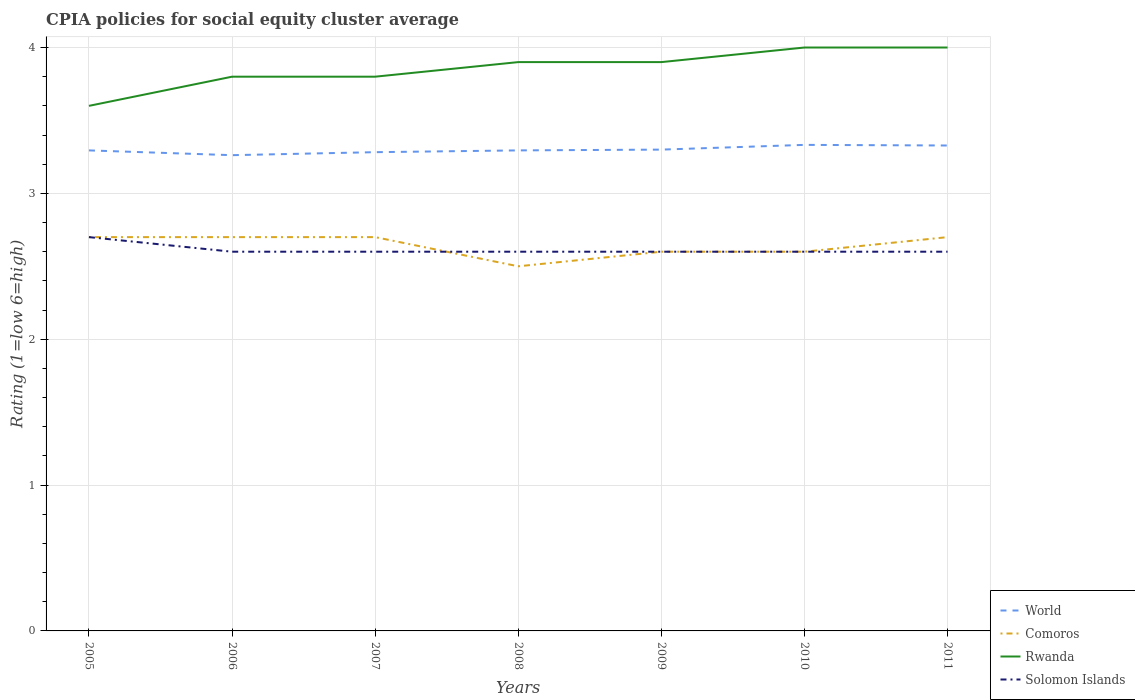How many different coloured lines are there?
Your answer should be very brief. 4. Does the line corresponding to World intersect with the line corresponding to Rwanda?
Your answer should be very brief. No. In which year was the CPIA rating in Rwanda maximum?
Provide a succinct answer. 2005. What is the total CPIA rating in Comoros in the graph?
Keep it short and to the point. 0. What is the difference between the highest and the second highest CPIA rating in Rwanda?
Provide a succinct answer. 0.4. What is the difference between the highest and the lowest CPIA rating in Solomon Islands?
Your response must be concise. 1. Is the CPIA rating in World strictly greater than the CPIA rating in Comoros over the years?
Your answer should be very brief. No. How many lines are there?
Your answer should be compact. 4. How many years are there in the graph?
Ensure brevity in your answer.  7. Does the graph contain any zero values?
Make the answer very short. No. Where does the legend appear in the graph?
Your answer should be very brief. Bottom right. How are the legend labels stacked?
Ensure brevity in your answer.  Vertical. What is the title of the graph?
Offer a terse response. CPIA policies for social equity cluster average. What is the label or title of the X-axis?
Provide a short and direct response. Years. What is the Rating (1=low 6=high) of World in 2005?
Provide a short and direct response. 3.29. What is the Rating (1=low 6=high) of World in 2006?
Offer a very short reply. 3.26. What is the Rating (1=low 6=high) of World in 2007?
Provide a short and direct response. 3.28. What is the Rating (1=low 6=high) of Rwanda in 2007?
Ensure brevity in your answer.  3.8. What is the Rating (1=low 6=high) in Solomon Islands in 2007?
Your response must be concise. 2.6. What is the Rating (1=low 6=high) in World in 2008?
Make the answer very short. 3.29. What is the Rating (1=low 6=high) of Rwanda in 2008?
Give a very brief answer. 3.9. What is the Rating (1=low 6=high) in Solomon Islands in 2008?
Offer a very short reply. 2.6. What is the Rating (1=low 6=high) of World in 2009?
Provide a succinct answer. 3.3. What is the Rating (1=low 6=high) of Comoros in 2009?
Keep it short and to the point. 2.6. What is the Rating (1=low 6=high) in World in 2010?
Your answer should be compact. 3.33. What is the Rating (1=low 6=high) in Solomon Islands in 2010?
Offer a very short reply. 2.6. What is the Rating (1=low 6=high) of World in 2011?
Make the answer very short. 3.33. What is the Rating (1=low 6=high) of Comoros in 2011?
Provide a succinct answer. 2.7. What is the Rating (1=low 6=high) in Rwanda in 2011?
Offer a terse response. 4. Across all years, what is the maximum Rating (1=low 6=high) in World?
Ensure brevity in your answer.  3.33. Across all years, what is the minimum Rating (1=low 6=high) in World?
Provide a succinct answer. 3.26. Across all years, what is the minimum Rating (1=low 6=high) in Comoros?
Give a very brief answer. 2.5. Across all years, what is the minimum Rating (1=low 6=high) in Rwanda?
Provide a succinct answer. 3.6. Across all years, what is the minimum Rating (1=low 6=high) of Solomon Islands?
Your answer should be compact. 2.6. What is the total Rating (1=low 6=high) in World in the graph?
Give a very brief answer. 23.09. What is the total Rating (1=low 6=high) in Comoros in the graph?
Your answer should be compact. 18.5. What is the total Rating (1=low 6=high) of Rwanda in the graph?
Offer a very short reply. 27. What is the difference between the Rating (1=low 6=high) in World in 2005 and that in 2006?
Offer a very short reply. 0.03. What is the difference between the Rating (1=low 6=high) of Rwanda in 2005 and that in 2006?
Provide a succinct answer. -0.2. What is the difference between the Rating (1=low 6=high) of Solomon Islands in 2005 and that in 2006?
Provide a short and direct response. 0.1. What is the difference between the Rating (1=low 6=high) of World in 2005 and that in 2007?
Your answer should be compact. 0.01. What is the difference between the Rating (1=low 6=high) in World in 2005 and that in 2008?
Keep it short and to the point. -0. What is the difference between the Rating (1=low 6=high) of Comoros in 2005 and that in 2008?
Your response must be concise. 0.2. What is the difference between the Rating (1=low 6=high) of Rwanda in 2005 and that in 2008?
Keep it short and to the point. -0.3. What is the difference between the Rating (1=low 6=high) of World in 2005 and that in 2009?
Keep it short and to the point. -0.01. What is the difference between the Rating (1=low 6=high) in Comoros in 2005 and that in 2009?
Your answer should be very brief. 0.1. What is the difference between the Rating (1=low 6=high) of Rwanda in 2005 and that in 2009?
Your answer should be very brief. -0.3. What is the difference between the Rating (1=low 6=high) in World in 2005 and that in 2010?
Your response must be concise. -0.04. What is the difference between the Rating (1=low 6=high) in Comoros in 2005 and that in 2010?
Provide a succinct answer. 0.1. What is the difference between the Rating (1=low 6=high) in Rwanda in 2005 and that in 2010?
Your response must be concise. -0.4. What is the difference between the Rating (1=low 6=high) of World in 2005 and that in 2011?
Provide a short and direct response. -0.03. What is the difference between the Rating (1=low 6=high) of Rwanda in 2005 and that in 2011?
Give a very brief answer. -0.4. What is the difference between the Rating (1=low 6=high) in World in 2006 and that in 2007?
Ensure brevity in your answer.  -0.02. What is the difference between the Rating (1=low 6=high) in Comoros in 2006 and that in 2007?
Keep it short and to the point. 0. What is the difference between the Rating (1=low 6=high) of Rwanda in 2006 and that in 2007?
Give a very brief answer. 0. What is the difference between the Rating (1=low 6=high) of World in 2006 and that in 2008?
Your answer should be very brief. -0.03. What is the difference between the Rating (1=low 6=high) of Comoros in 2006 and that in 2008?
Keep it short and to the point. 0.2. What is the difference between the Rating (1=low 6=high) in Rwanda in 2006 and that in 2008?
Ensure brevity in your answer.  -0.1. What is the difference between the Rating (1=low 6=high) in Solomon Islands in 2006 and that in 2008?
Your answer should be very brief. 0. What is the difference between the Rating (1=low 6=high) in World in 2006 and that in 2009?
Keep it short and to the point. -0.04. What is the difference between the Rating (1=low 6=high) of World in 2006 and that in 2010?
Your answer should be compact. -0.07. What is the difference between the Rating (1=low 6=high) in Solomon Islands in 2006 and that in 2010?
Make the answer very short. 0. What is the difference between the Rating (1=low 6=high) of World in 2006 and that in 2011?
Offer a very short reply. -0.07. What is the difference between the Rating (1=low 6=high) in Comoros in 2006 and that in 2011?
Your answer should be compact. 0. What is the difference between the Rating (1=low 6=high) of Solomon Islands in 2006 and that in 2011?
Make the answer very short. 0. What is the difference between the Rating (1=low 6=high) of World in 2007 and that in 2008?
Provide a succinct answer. -0.01. What is the difference between the Rating (1=low 6=high) in Comoros in 2007 and that in 2008?
Ensure brevity in your answer.  0.2. What is the difference between the Rating (1=low 6=high) in Rwanda in 2007 and that in 2008?
Give a very brief answer. -0.1. What is the difference between the Rating (1=low 6=high) in Solomon Islands in 2007 and that in 2008?
Keep it short and to the point. 0. What is the difference between the Rating (1=low 6=high) in World in 2007 and that in 2009?
Your answer should be compact. -0.02. What is the difference between the Rating (1=low 6=high) in Comoros in 2007 and that in 2009?
Your answer should be compact. 0.1. What is the difference between the Rating (1=low 6=high) in Rwanda in 2007 and that in 2009?
Keep it short and to the point. -0.1. What is the difference between the Rating (1=low 6=high) in Solomon Islands in 2007 and that in 2009?
Make the answer very short. 0. What is the difference between the Rating (1=low 6=high) in Rwanda in 2007 and that in 2010?
Your response must be concise. -0.2. What is the difference between the Rating (1=low 6=high) in Solomon Islands in 2007 and that in 2010?
Provide a short and direct response. 0. What is the difference between the Rating (1=low 6=high) of World in 2007 and that in 2011?
Keep it short and to the point. -0.05. What is the difference between the Rating (1=low 6=high) of Rwanda in 2007 and that in 2011?
Provide a succinct answer. -0.2. What is the difference between the Rating (1=low 6=high) of Solomon Islands in 2007 and that in 2011?
Give a very brief answer. 0. What is the difference between the Rating (1=low 6=high) of World in 2008 and that in 2009?
Ensure brevity in your answer.  -0.01. What is the difference between the Rating (1=low 6=high) of Comoros in 2008 and that in 2009?
Provide a short and direct response. -0.1. What is the difference between the Rating (1=low 6=high) in World in 2008 and that in 2010?
Provide a succinct answer. -0.04. What is the difference between the Rating (1=low 6=high) in Comoros in 2008 and that in 2010?
Provide a short and direct response. -0.1. What is the difference between the Rating (1=low 6=high) of Rwanda in 2008 and that in 2010?
Provide a short and direct response. -0.1. What is the difference between the Rating (1=low 6=high) in World in 2008 and that in 2011?
Offer a terse response. -0.03. What is the difference between the Rating (1=low 6=high) of Rwanda in 2008 and that in 2011?
Offer a very short reply. -0.1. What is the difference between the Rating (1=low 6=high) in World in 2009 and that in 2010?
Offer a very short reply. -0.03. What is the difference between the Rating (1=low 6=high) in Solomon Islands in 2009 and that in 2010?
Offer a terse response. 0. What is the difference between the Rating (1=low 6=high) in World in 2009 and that in 2011?
Your answer should be compact. -0.03. What is the difference between the Rating (1=low 6=high) of Solomon Islands in 2009 and that in 2011?
Offer a very short reply. 0. What is the difference between the Rating (1=low 6=high) in World in 2010 and that in 2011?
Your answer should be compact. 0. What is the difference between the Rating (1=low 6=high) in Comoros in 2010 and that in 2011?
Offer a very short reply. -0.1. What is the difference between the Rating (1=low 6=high) of World in 2005 and the Rating (1=low 6=high) of Comoros in 2006?
Offer a very short reply. 0.59. What is the difference between the Rating (1=low 6=high) in World in 2005 and the Rating (1=low 6=high) in Rwanda in 2006?
Give a very brief answer. -0.51. What is the difference between the Rating (1=low 6=high) in World in 2005 and the Rating (1=low 6=high) in Solomon Islands in 2006?
Your answer should be compact. 0.69. What is the difference between the Rating (1=low 6=high) in World in 2005 and the Rating (1=low 6=high) in Comoros in 2007?
Make the answer very short. 0.59. What is the difference between the Rating (1=low 6=high) in World in 2005 and the Rating (1=low 6=high) in Rwanda in 2007?
Your response must be concise. -0.51. What is the difference between the Rating (1=low 6=high) in World in 2005 and the Rating (1=low 6=high) in Solomon Islands in 2007?
Ensure brevity in your answer.  0.69. What is the difference between the Rating (1=low 6=high) in World in 2005 and the Rating (1=low 6=high) in Comoros in 2008?
Ensure brevity in your answer.  0.79. What is the difference between the Rating (1=low 6=high) in World in 2005 and the Rating (1=low 6=high) in Rwanda in 2008?
Offer a very short reply. -0.61. What is the difference between the Rating (1=low 6=high) of World in 2005 and the Rating (1=low 6=high) of Solomon Islands in 2008?
Your response must be concise. 0.69. What is the difference between the Rating (1=low 6=high) of Comoros in 2005 and the Rating (1=low 6=high) of Rwanda in 2008?
Keep it short and to the point. -1.2. What is the difference between the Rating (1=low 6=high) in Rwanda in 2005 and the Rating (1=low 6=high) in Solomon Islands in 2008?
Your answer should be compact. 1. What is the difference between the Rating (1=low 6=high) of World in 2005 and the Rating (1=low 6=high) of Comoros in 2009?
Provide a short and direct response. 0.69. What is the difference between the Rating (1=low 6=high) in World in 2005 and the Rating (1=low 6=high) in Rwanda in 2009?
Offer a terse response. -0.61. What is the difference between the Rating (1=low 6=high) of World in 2005 and the Rating (1=low 6=high) of Solomon Islands in 2009?
Offer a very short reply. 0.69. What is the difference between the Rating (1=low 6=high) in Comoros in 2005 and the Rating (1=low 6=high) in Rwanda in 2009?
Offer a very short reply. -1.2. What is the difference between the Rating (1=low 6=high) of Rwanda in 2005 and the Rating (1=low 6=high) of Solomon Islands in 2009?
Offer a very short reply. 1. What is the difference between the Rating (1=low 6=high) in World in 2005 and the Rating (1=low 6=high) in Comoros in 2010?
Offer a terse response. 0.69. What is the difference between the Rating (1=low 6=high) in World in 2005 and the Rating (1=low 6=high) in Rwanda in 2010?
Your response must be concise. -0.71. What is the difference between the Rating (1=low 6=high) of World in 2005 and the Rating (1=low 6=high) of Solomon Islands in 2010?
Make the answer very short. 0.69. What is the difference between the Rating (1=low 6=high) in Rwanda in 2005 and the Rating (1=low 6=high) in Solomon Islands in 2010?
Make the answer very short. 1. What is the difference between the Rating (1=low 6=high) of World in 2005 and the Rating (1=low 6=high) of Comoros in 2011?
Ensure brevity in your answer.  0.59. What is the difference between the Rating (1=low 6=high) in World in 2005 and the Rating (1=low 6=high) in Rwanda in 2011?
Keep it short and to the point. -0.71. What is the difference between the Rating (1=low 6=high) of World in 2005 and the Rating (1=low 6=high) of Solomon Islands in 2011?
Your response must be concise. 0.69. What is the difference between the Rating (1=low 6=high) of Rwanda in 2005 and the Rating (1=low 6=high) of Solomon Islands in 2011?
Make the answer very short. 1. What is the difference between the Rating (1=low 6=high) of World in 2006 and the Rating (1=low 6=high) of Comoros in 2007?
Give a very brief answer. 0.56. What is the difference between the Rating (1=low 6=high) of World in 2006 and the Rating (1=low 6=high) of Rwanda in 2007?
Offer a very short reply. -0.54. What is the difference between the Rating (1=low 6=high) in World in 2006 and the Rating (1=low 6=high) in Solomon Islands in 2007?
Offer a terse response. 0.66. What is the difference between the Rating (1=low 6=high) in Comoros in 2006 and the Rating (1=low 6=high) in Rwanda in 2007?
Your answer should be compact. -1.1. What is the difference between the Rating (1=low 6=high) in Comoros in 2006 and the Rating (1=low 6=high) in Solomon Islands in 2007?
Provide a short and direct response. 0.1. What is the difference between the Rating (1=low 6=high) of World in 2006 and the Rating (1=low 6=high) of Comoros in 2008?
Your answer should be compact. 0.76. What is the difference between the Rating (1=low 6=high) in World in 2006 and the Rating (1=low 6=high) in Rwanda in 2008?
Provide a short and direct response. -0.64. What is the difference between the Rating (1=low 6=high) in World in 2006 and the Rating (1=low 6=high) in Solomon Islands in 2008?
Provide a short and direct response. 0.66. What is the difference between the Rating (1=low 6=high) in World in 2006 and the Rating (1=low 6=high) in Comoros in 2009?
Offer a very short reply. 0.66. What is the difference between the Rating (1=low 6=high) of World in 2006 and the Rating (1=low 6=high) of Rwanda in 2009?
Offer a very short reply. -0.64. What is the difference between the Rating (1=low 6=high) of World in 2006 and the Rating (1=low 6=high) of Solomon Islands in 2009?
Provide a succinct answer. 0.66. What is the difference between the Rating (1=low 6=high) in World in 2006 and the Rating (1=low 6=high) in Comoros in 2010?
Ensure brevity in your answer.  0.66. What is the difference between the Rating (1=low 6=high) of World in 2006 and the Rating (1=low 6=high) of Rwanda in 2010?
Your answer should be very brief. -0.74. What is the difference between the Rating (1=low 6=high) of World in 2006 and the Rating (1=low 6=high) of Solomon Islands in 2010?
Provide a short and direct response. 0.66. What is the difference between the Rating (1=low 6=high) of World in 2006 and the Rating (1=low 6=high) of Comoros in 2011?
Keep it short and to the point. 0.56. What is the difference between the Rating (1=low 6=high) in World in 2006 and the Rating (1=low 6=high) in Rwanda in 2011?
Provide a short and direct response. -0.74. What is the difference between the Rating (1=low 6=high) in World in 2006 and the Rating (1=low 6=high) in Solomon Islands in 2011?
Offer a very short reply. 0.66. What is the difference between the Rating (1=low 6=high) of Comoros in 2006 and the Rating (1=low 6=high) of Rwanda in 2011?
Your answer should be compact. -1.3. What is the difference between the Rating (1=low 6=high) in Comoros in 2006 and the Rating (1=low 6=high) in Solomon Islands in 2011?
Make the answer very short. 0.1. What is the difference between the Rating (1=low 6=high) in World in 2007 and the Rating (1=low 6=high) in Comoros in 2008?
Your response must be concise. 0.78. What is the difference between the Rating (1=low 6=high) of World in 2007 and the Rating (1=low 6=high) of Rwanda in 2008?
Ensure brevity in your answer.  -0.62. What is the difference between the Rating (1=low 6=high) of World in 2007 and the Rating (1=low 6=high) of Solomon Islands in 2008?
Keep it short and to the point. 0.68. What is the difference between the Rating (1=low 6=high) of Comoros in 2007 and the Rating (1=low 6=high) of Solomon Islands in 2008?
Your answer should be compact. 0.1. What is the difference between the Rating (1=low 6=high) in Rwanda in 2007 and the Rating (1=low 6=high) in Solomon Islands in 2008?
Give a very brief answer. 1.2. What is the difference between the Rating (1=low 6=high) in World in 2007 and the Rating (1=low 6=high) in Comoros in 2009?
Offer a terse response. 0.68. What is the difference between the Rating (1=low 6=high) in World in 2007 and the Rating (1=low 6=high) in Rwanda in 2009?
Offer a very short reply. -0.62. What is the difference between the Rating (1=low 6=high) in World in 2007 and the Rating (1=low 6=high) in Solomon Islands in 2009?
Your answer should be very brief. 0.68. What is the difference between the Rating (1=low 6=high) of Comoros in 2007 and the Rating (1=low 6=high) of Solomon Islands in 2009?
Keep it short and to the point. 0.1. What is the difference between the Rating (1=low 6=high) of Rwanda in 2007 and the Rating (1=low 6=high) of Solomon Islands in 2009?
Ensure brevity in your answer.  1.2. What is the difference between the Rating (1=low 6=high) in World in 2007 and the Rating (1=low 6=high) in Comoros in 2010?
Your response must be concise. 0.68. What is the difference between the Rating (1=low 6=high) of World in 2007 and the Rating (1=low 6=high) of Rwanda in 2010?
Offer a very short reply. -0.72. What is the difference between the Rating (1=low 6=high) of World in 2007 and the Rating (1=low 6=high) of Solomon Islands in 2010?
Keep it short and to the point. 0.68. What is the difference between the Rating (1=low 6=high) in Comoros in 2007 and the Rating (1=low 6=high) in Rwanda in 2010?
Ensure brevity in your answer.  -1.3. What is the difference between the Rating (1=low 6=high) of Rwanda in 2007 and the Rating (1=low 6=high) of Solomon Islands in 2010?
Offer a terse response. 1.2. What is the difference between the Rating (1=low 6=high) of World in 2007 and the Rating (1=low 6=high) of Comoros in 2011?
Provide a short and direct response. 0.58. What is the difference between the Rating (1=low 6=high) of World in 2007 and the Rating (1=low 6=high) of Rwanda in 2011?
Make the answer very short. -0.72. What is the difference between the Rating (1=low 6=high) in World in 2007 and the Rating (1=low 6=high) in Solomon Islands in 2011?
Ensure brevity in your answer.  0.68. What is the difference between the Rating (1=low 6=high) in Comoros in 2007 and the Rating (1=low 6=high) in Rwanda in 2011?
Make the answer very short. -1.3. What is the difference between the Rating (1=low 6=high) in Comoros in 2007 and the Rating (1=low 6=high) in Solomon Islands in 2011?
Offer a very short reply. 0.1. What is the difference between the Rating (1=low 6=high) in Rwanda in 2007 and the Rating (1=low 6=high) in Solomon Islands in 2011?
Keep it short and to the point. 1.2. What is the difference between the Rating (1=low 6=high) of World in 2008 and the Rating (1=low 6=high) of Comoros in 2009?
Keep it short and to the point. 0.69. What is the difference between the Rating (1=low 6=high) of World in 2008 and the Rating (1=low 6=high) of Rwanda in 2009?
Offer a terse response. -0.61. What is the difference between the Rating (1=low 6=high) of World in 2008 and the Rating (1=low 6=high) of Solomon Islands in 2009?
Make the answer very short. 0.69. What is the difference between the Rating (1=low 6=high) of World in 2008 and the Rating (1=low 6=high) of Comoros in 2010?
Keep it short and to the point. 0.69. What is the difference between the Rating (1=low 6=high) of World in 2008 and the Rating (1=low 6=high) of Rwanda in 2010?
Provide a short and direct response. -0.71. What is the difference between the Rating (1=low 6=high) in World in 2008 and the Rating (1=low 6=high) in Solomon Islands in 2010?
Your response must be concise. 0.69. What is the difference between the Rating (1=low 6=high) of Comoros in 2008 and the Rating (1=low 6=high) of Rwanda in 2010?
Your answer should be very brief. -1.5. What is the difference between the Rating (1=low 6=high) of Comoros in 2008 and the Rating (1=low 6=high) of Solomon Islands in 2010?
Offer a very short reply. -0.1. What is the difference between the Rating (1=low 6=high) in Rwanda in 2008 and the Rating (1=low 6=high) in Solomon Islands in 2010?
Ensure brevity in your answer.  1.3. What is the difference between the Rating (1=low 6=high) in World in 2008 and the Rating (1=low 6=high) in Comoros in 2011?
Your answer should be very brief. 0.59. What is the difference between the Rating (1=low 6=high) in World in 2008 and the Rating (1=low 6=high) in Rwanda in 2011?
Offer a very short reply. -0.71. What is the difference between the Rating (1=low 6=high) of World in 2008 and the Rating (1=low 6=high) of Solomon Islands in 2011?
Provide a succinct answer. 0.69. What is the difference between the Rating (1=low 6=high) of Comoros in 2008 and the Rating (1=low 6=high) of Rwanda in 2011?
Keep it short and to the point. -1.5. What is the difference between the Rating (1=low 6=high) in Rwanda in 2008 and the Rating (1=low 6=high) in Solomon Islands in 2011?
Your response must be concise. 1.3. What is the difference between the Rating (1=low 6=high) of World in 2009 and the Rating (1=low 6=high) of Rwanda in 2010?
Make the answer very short. -0.7. What is the difference between the Rating (1=low 6=high) of Comoros in 2009 and the Rating (1=low 6=high) of Rwanda in 2010?
Offer a very short reply. -1.4. What is the difference between the Rating (1=low 6=high) in Rwanda in 2009 and the Rating (1=low 6=high) in Solomon Islands in 2010?
Offer a terse response. 1.3. What is the difference between the Rating (1=low 6=high) of World in 2009 and the Rating (1=low 6=high) of Rwanda in 2011?
Your answer should be very brief. -0.7. What is the difference between the Rating (1=low 6=high) in Comoros in 2009 and the Rating (1=low 6=high) in Rwanda in 2011?
Offer a terse response. -1.4. What is the difference between the Rating (1=low 6=high) in World in 2010 and the Rating (1=low 6=high) in Comoros in 2011?
Your answer should be compact. 0.63. What is the difference between the Rating (1=low 6=high) of World in 2010 and the Rating (1=low 6=high) of Rwanda in 2011?
Provide a short and direct response. -0.67. What is the difference between the Rating (1=low 6=high) in World in 2010 and the Rating (1=low 6=high) in Solomon Islands in 2011?
Give a very brief answer. 0.73. What is the difference between the Rating (1=low 6=high) of Comoros in 2010 and the Rating (1=low 6=high) of Solomon Islands in 2011?
Provide a succinct answer. 0. What is the difference between the Rating (1=low 6=high) of Rwanda in 2010 and the Rating (1=low 6=high) of Solomon Islands in 2011?
Give a very brief answer. 1.4. What is the average Rating (1=low 6=high) in World per year?
Provide a short and direct response. 3.3. What is the average Rating (1=low 6=high) of Comoros per year?
Provide a short and direct response. 2.64. What is the average Rating (1=low 6=high) of Rwanda per year?
Provide a short and direct response. 3.86. What is the average Rating (1=low 6=high) in Solomon Islands per year?
Your answer should be very brief. 2.61. In the year 2005, what is the difference between the Rating (1=low 6=high) of World and Rating (1=low 6=high) of Comoros?
Your answer should be very brief. 0.59. In the year 2005, what is the difference between the Rating (1=low 6=high) in World and Rating (1=low 6=high) in Rwanda?
Your answer should be compact. -0.31. In the year 2005, what is the difference between the Rating (1=low 6=high) in World and Rating (1=low 6=high) in Solomon Islands?
Provide a short and direct response. 0.59. In the year 2005, what is the difference between the Rating (1=low 6=high) of Comoros and Rating (1=low 6=high) of Solomon Islands?
Make the answer very short. 0. In the year 2006, what is the difference between the Rating (1=low 6=high) of World and Rating (1=low 6=high) of Comoros?
Provide a succinct answer. 0.56. In the year 2006, what is the difference between the Rating (1=low 6=high) in World and Rating (1=low 6=high) in Rwanda?
Offer a terse response. -0.54. In the year 2006, what is the difference between the Rating (1=low 6=high) of World and Rating (1=low 6=high) of Solomon Islands?
Make the answer very short. 0.66. In the year 2006, what is the difference between the Rating (1=low 6=high) of Comoros and Rating (1=low 6=high) of Rwanda?
Offer a very short reply. -1.1. In the year 2006, what is the difference between the Rating (1=low 6=high) in Comoros and Rating (1=low 6=high) in Solomon Islands?
Make the answer very short. 0.1. In the year 2007, what is the difference between the Rating (1=low 6=high) of World and Rating (1=low 6=high) of Comoros?
Provide a succinct answer. 0.58. In the year 2007, what is the difference between the Rating (1=low 6=high) in World and Rating (1=low 6=high) in Rwanda?
Ensure brevity in your answer.  -0.52. In the year 2007, what is the difference between the Rating (1=low 6=high) of World and Rating (1=low 6=high) of Solomon Islands?
Your answer should be very brief. 0.68. In the year 2007, what is the difference between the Rating (1=low 6=high) in Comoros and Rating (1=low 6=high) in Rwanda?
Make the answer very short. -1.1. In the year 2007, what is the difference between the Rating (1=low 6=high) in Comoros and Rating (1=low 6=high) in Solomon Islands?
Keep it short and to the point. 0.1. In the year 2007, what is the difference between the Rating (1=low 6=high) in Rwanda and Rating (1=low 6=high) in Solomon Islands?
Your response must be concise. 1.2. In the year 2008, what is the difference between the Rating (1=low 6=high) of World and Rating (1=low 6=high) of Comoros?
Ensure brevity in your answer.  0.79. In the year 2008, what is the difference between the Rating (1=low 6=high) of World and Rating (1=low 6=high) of Rwanda?
Make the answer very short. -0.61. In the year 2008, what is the difference between the Rating (1=low 6=high) in World and Rating (1=low 6=high) in Solomon Islands?
Ensure brevity in your answer.  0.69. In the year 2008, what is the difference between the Rating (1=low 6=high) in Comoros and Rating (1=low 6=high) in Rwanda?
Offer a terse response. -1.4. In the year 2009, what is the difference between the Rating (1=low 6=high) in World and Rating (1=low 6=high) in Comoros?
Provide a succinct answer. 0.7. In the year 2009, what is the difference between the Rating (1=low 6=high) in World and Rating (1=low 6=high) in Rwanda?
Keep it short and to the point. -0.6. In the year 2010, what is the difference between the Rating (1=low 6=high) of World and Rating (1=low 6=high) of Comoros?
Offer a very short reply. 0.73. In the year 2010, what is the difference between the Rating (1=low 6=high) of World and Rating (1=low 6=high) of Rwanda?
Give a very brief answer. -0.67. In the year 2010, what is the difference between the Rating (1=low 6=high) in World and Rating (1=low 6=high) in Solomon Islands?
Your answer should be very brief. 0.73. In the year 2011, what is the difference between the Rating (1=low 6=high) of World and Rating (1=low 6=high) of Comoros?
Provide a short and direct response. 0.63. In the year 2011, what is the difference between the Rating (1=low 6=high) in World and Rating (1=low 6=high) in Rwanda?
Your response must be concise. -0.67. In the year 2011, what is the difference between the Rating (1=low 6=high) of World and Rating (1=low 6=high) of Solomon Islands?
Ensure brevity in your answer.  0.73. In the year 2011, what is the difference between the Rating (1=low 6=high) in Comoros and Rating (1=low 6=high) in Solomon Islands?
Make the answer very short. 0.1. In the year 2011, what is the difference between the Rating (1=low 6=high) of Rwanda and Rating (1=low 6=high) of Solomon Islands?
Keep it short and to the point. 1.4. What is the ratio of the Rating (1=low 6=high) in World in 2005 to that in 2007?
Keep it short and to the point. 1. What is the ratio of the Rating (1=low 6=high) of Rwanda in 2005 to that in 2007?
Ensure brevity in your answer.  0.95. What is the ratio of the Rating (1=low 6=high) of World in 2005 to that in 2008?
Your answer should be compact. 1. What is the ratio of the Rating (1=low 6=high) of Solomon Islands in 2005 to that in 2008?
Offer a terse response. 1.04. What is the ratio of the Rating (1=low 6=high) of Comoros in 2005 to that in 2009?
Make the answer very short. 1.04. What is the ratio of the Rating (1=low 6=high) of Solomon Islands in 2005 to that in 2009?
Give a very brief answer. 1.04. What is the ratio of the Rating (1=low 6=high) of World in 2005 to that in 2010?
Ensure brevity in your answer.  0.99. What is the ratio of the Rating (1=low 6=high) in Rwanda in 2005 to that in 2010?
Ensure brevity in your answer.  0.9. What is the ratio of the Rating (1=low 6=high) in Solomon Islands in 2005 to that in 2010?
Your answer should be very brief. 1.04. What is the ratio of the Rating (1=low 6=high) of Comoros in 2005 to that in 2011?
Offer a terse response. 1. What is the ratio of the Rating (1=low 6=high) in Rwanda in 2005 to that in 2011?
Your answer should be compact. 0.9. What is the ratio of the Rating (1=low 6=high) of Solomon Islands in 2005 to that in 2011?
Make the answer very short. 1.04. What is the ratio of the Rating (1=low 6=high) in World in 2006 to that in 2007?
Provide a succinct answer. 0.99. What is the ratio of the Rating (1=low 6=high) of Rwanda in 2006 to that in 2008?
Provide a succinct answer. 0.97. What is the ratio of the Rating (1=low 6=high) in Solomon Islands in 2006 to that in 2008?
Make the answer very short. 1. What is the ratio of the Rating (1=low 6=high) in World in 2006 to that in 2009?
Ensure brevity in your answer.  0.99. What is the ratio of the Rating (1=low 6=high) of Comoros in 2006 to that in 2009?
Your response must be concise. 1.04. What is the ratio of the Rating (1=low 6=high) in Rwanda in 2006 to that in 2009?
Provide a short and direct response. 0.97. What is the ratio of the Rating (1=low 6=high) of World in 2006 to that in 2010?
Ensure brevity in your answer.  0.98. What is the ratio of the Rating (1=low 6=high) of Rwanda in 2006 to that in 2010?
Ensure brevity in your answer.  0.95. What is the ratio of the Rating (1=low 6=high) in World in 2006 to that in 2011?
Provide a succinct answer. 0.98. What is the ratio of the Rating (1=low 6=high) of Rwanda in 2006 to that in 2011?
Ensure brevity in your answer.  0.95. What is the ratio of the Rating (1=low 6=high) of World in 2007 to that in 2008?
Your answer should be very brief. 1. What is the ratio of the Rating (1=low 6=high) in Comoros in 2007 to that in 2008?
Your answer should be very brief. 1.08. What is the ratio of the Rating (1=low 6=high) of Rwanda in 2007 to that in 2008?
Keep it short and to the point. 0.97. What is the ratio of the Rating (1=low 6=high) in Solomon Islands in 2007 to that in 2008?
Your answer should be very brief. 1. What is the ratio of the Rating (1=low 6=high) of World in 2007 to that in 2009?
Ensure brevity in your answer.  0.99. What is the ratio of the Rating (1=low 6=high) in Comoros in 2007 to that in 2009?
Your answer should be very brief. 1.04. What is the ratio of the Rating (1=low 6=high) in Rwanda in 2007 to that in 2009?
Offer a terse response. 0.97. What is the ratio of the Rating (1=low 6=high) of World in 2007 to that in 2010?
Your answer should be very brief. 0.98. What is the ratio of the Rating (1=low 6=high) in World in 2007 to that in 2011?
Offer a very short reply. 0.99. What is the ratio of the Rating (1=low 6=high) of Solomon Islands in 2007 to that in 2011?
Offer a terse response. 1. What is the ratio of the Rating (1=low 6=high) of Comoros in 2008 to that in 2009?
Offer a very short reply. 0.96. What is the ratio of the Rating (1=low 6=high) of World in 2008 to that in 2010?
Ensure brevity in your answer.  0.99. What is the ratio of the Rating (1=low 6=high) of Comoros in 2008 to that in 2010?
Provide a succinct answer. 0.96. What is the ratio of the Rating (1=low 6=high) of Solomon Islands in 2008 to that in 2010?
Offer a terse response. 1. What is the ratio of the Rating (1=low 6=high) of World in 2008 to that in 2011?
Your response must be concise. 0.99. What is the ratio of the Rating (1=low 6=high) in Comoros in 2008 to that in 2011?
Offer a terse response. 0.93. What is the ratio of the Rating (1=low 6=high) in Rwanda in 2008 to that in 2011?
Your answer should be compact. 0.97. What is the ratio of the Rating (1=low 6=high) of Solomon Islands in 2008 to that in 2011?
Give a very brief answer. 1. What is the ratio of the Rating (1=low 6=high) in World in 2009 to that in 2010?
Make the answer very short. 0.99. What is the ratio of the Rating (1=low 6=high) of Comoros in 2009 to that in 2010?
Your response must be concise. 1. What is the ratio of the Rating (1=low 6=high) of Rwanda in 2009 to that in 2010?
Give a very brief answer. 0.97. What is the ratio of the Rating (1=low 6=high) in Solomon Islands in 2009 to that in 2010?
Provide a succinct answer. 1. What is the ratio of the Rating (1=low 6=high) in Rwanda in 2009 to that in 2011?
Provide a short and direct response. 0.97. What is the ratio of the Rating (1=low 6=high) of Solomon Islands in 2009 to that in 2011?
Ensure brevity in your answer.  1. What is the ratio of the Rating (1=low 6=high) of World in 2010 to that in 2011?
Your response must be concise. 1. What is the difference between the highest and the second highest Rating (1=low 6=high) of World?
Make the answer very short. 0. What is the difference between the highest and the lowest Rating (1=low 6=high) of World?
Provide a succinct answer. 0.07. What is the difference between the highest and the lowest Rating (1=low 6=high) in Solomon Islands?
Provide a short and direct response. 0.1. 